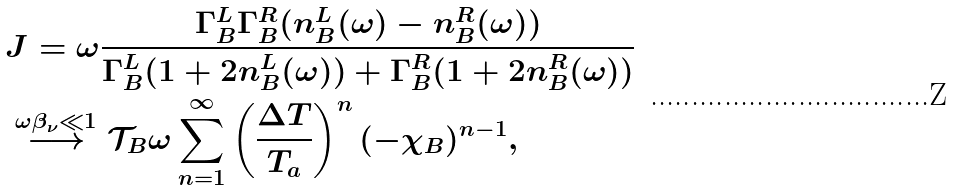Convert formula to latex. <formula><loc_0><loc_0><loc_500><loc_500>& J = \omega \frac { \Gamma _ { B } ^ { L } \Gamma _ { B } ^ { R } ( n _ { B } ^ { L } ( \omega ) - n _ { B } ^ { R } ( \omega ) ) } { \Gamma _ { B } ^ { L } ( 1 + 2 n _ { B } ^ { L } ( \omega ) ) + \Gamma _ { B } ^ { R } ( 1 + 2 n _ { B } ^ { R } ( \omega ) ) } \\ & \stackrel { \omega \beta _ { \nu } \ll 1 } { \longrightarrow } \mathcal { T } _ { B } \omega \sum _ { n = 1 } ^ { \infty } \left ( \frac { \Delta T } { T _ { a } } \right ) ^ { n } ( - \chi _ { B } ) ^ { n - 1 } ,</formula> 